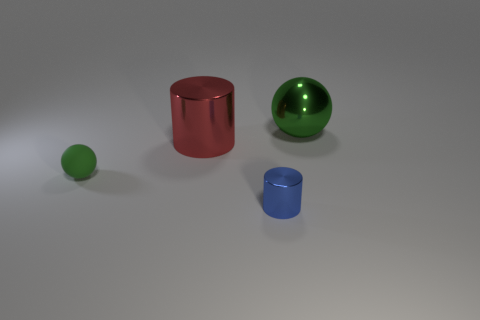Add 1 tiny rubber spheres. How many objects exist? 5 Add 1 tiny green matte spheres. How many tiny green matte spheres are left? 2 Add 2 big brown rubber spheres. How many big brown rubber spheres exist? 2 Subtract 1 green spheres. How many objects are left? 3 Subtract all red cylinders. Subtract all blue spheres. How many cylinders are left? 1 Subtract all tiny blue objects. Subtract all red cylinders. How many objects are left? 2 